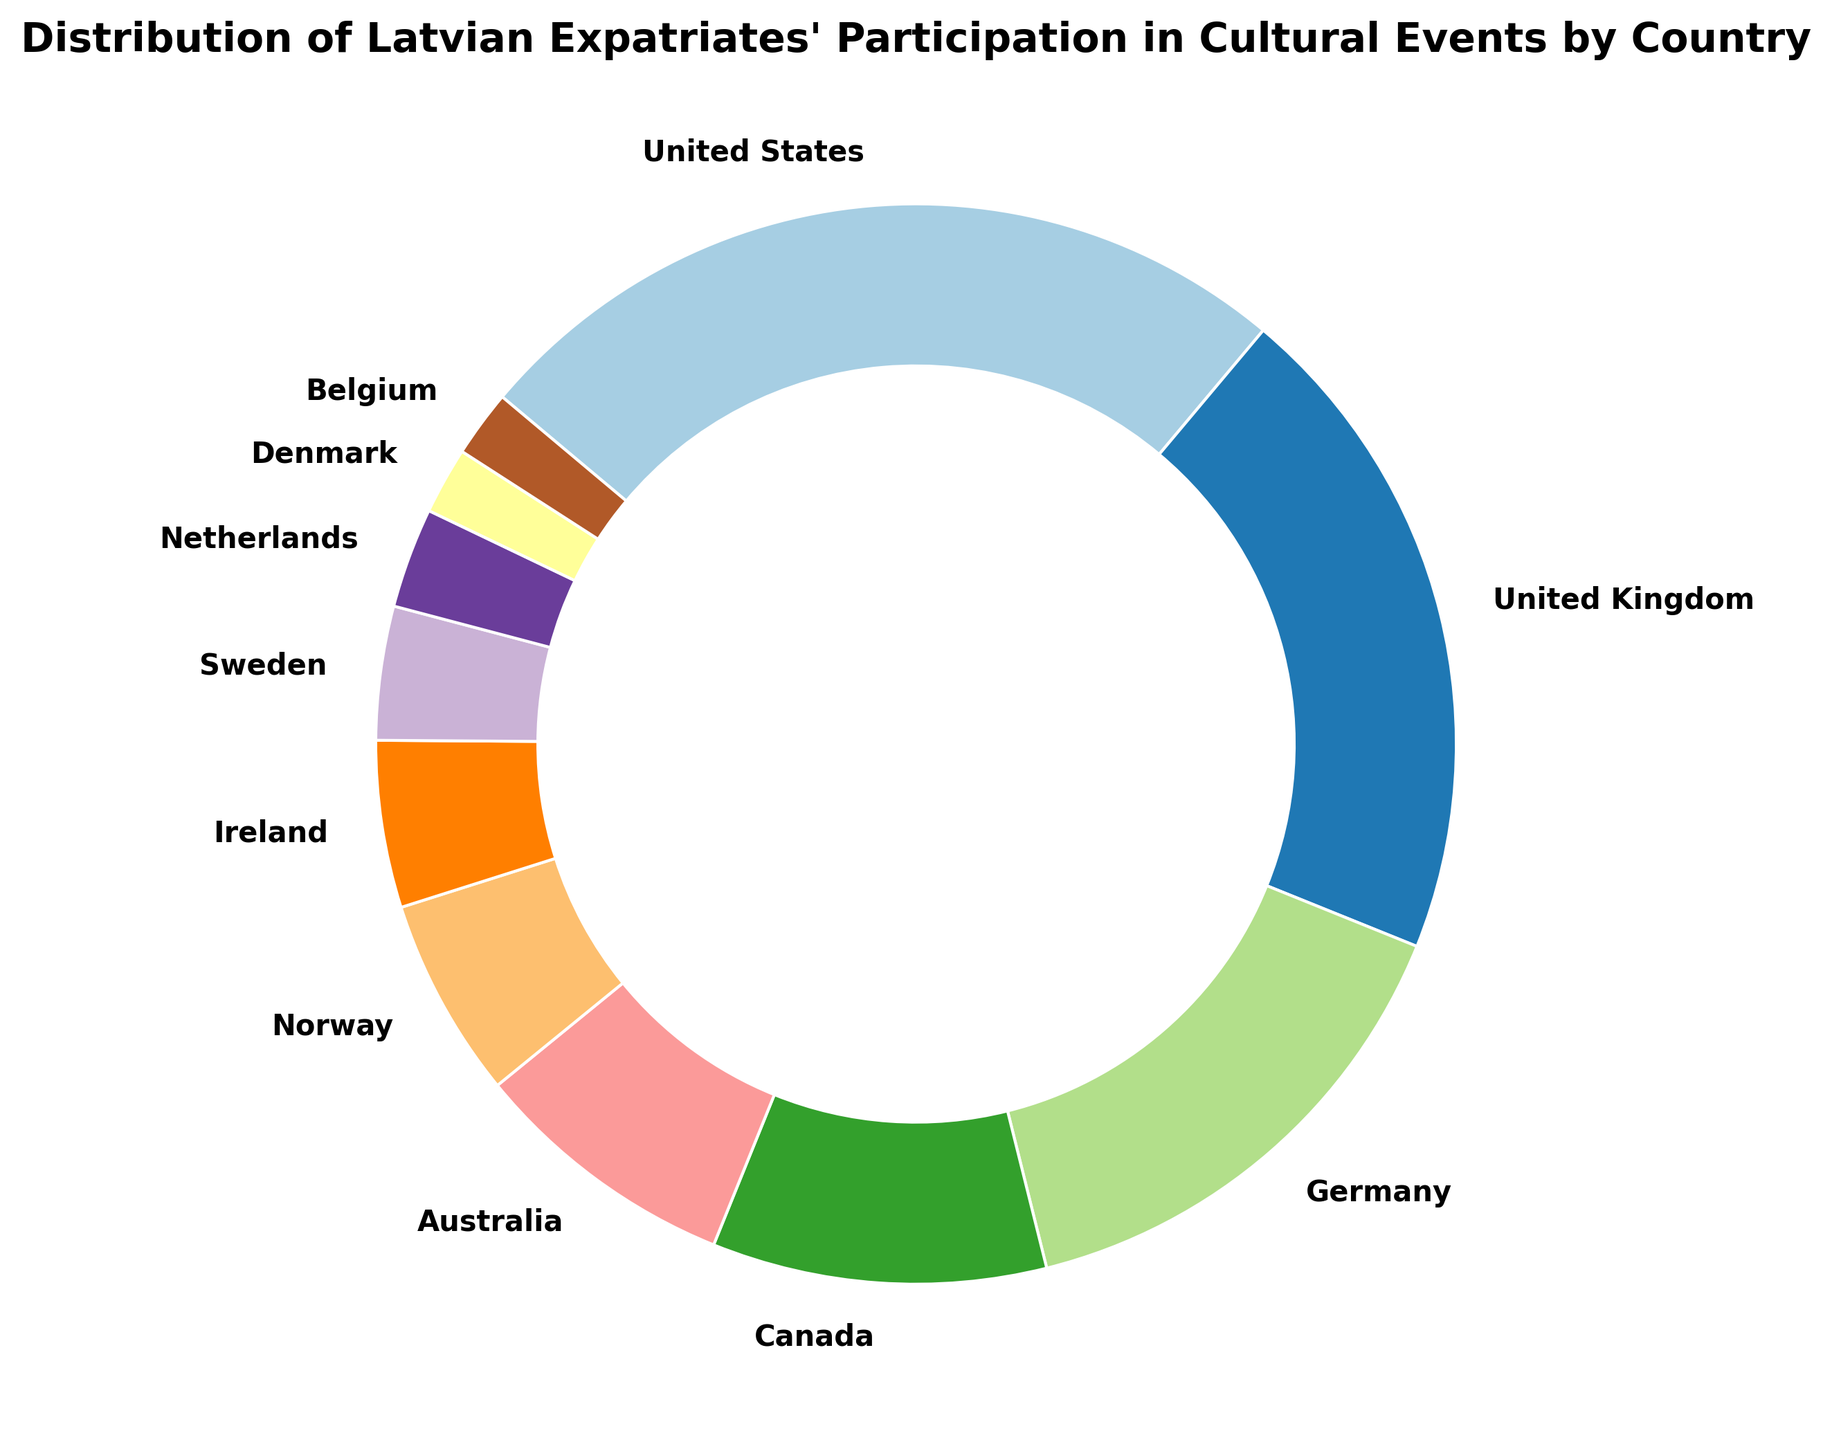What country has the highest participation percentage? The United States has the highest participation percentage. The ring chart shows that 25% of Latvian expatriates' participation in cultural events occurs in the United States.
Answer: United States Which country has the smallest participation percentage? The ring chart indicates that both Denmark and Belgium have the smallest participation percentage, each with 2%.
Answer: Denmark and Belgium What is the combined participation percentage of Latvian expatriates in the United States and the United Kingdom? Summing the participation percentages from the United States (25%) and the United Kingdom (20%) gives 25% + 20% = 45%.
Answer: 45% Which country has a higher participation percentage, Norway or Sweden? Norway has a higher participation percentage with 6%, compared to Sweden's 4%.
Answer: Norway What is the total percentage for Germany, Canada, and Australia? Adding the participation percentages of Germany (15%), Canada (10%), and Australia (8%) gives 15% + 10% + 8% = 33%.
Answer: 33% How many countries have more than 10% participation? The ring chart shows that three countries have more than 10% participation: the United States (25%), the United Kingdom (20%), and Germany (15%).
Answer: 3 Is the participation percentage of Ireland higher or lower than that of Sweden? Ireland has a higher participation percentage (5%) compared to Sweden (4%).
Answer: Higher What is the participation difference between the Netherlands and the United Kingdom? The participation percentage in the United Kingdom is 20%, while in the Netherlands, it is 3%. The difference is 20% - 3% = 17%.
Answer: 17% Between Canada and Australia, which country has a lower participation percentage? Australia has a lower participation percentage (8%) compared to Canada (10%).
Answer: Australia 